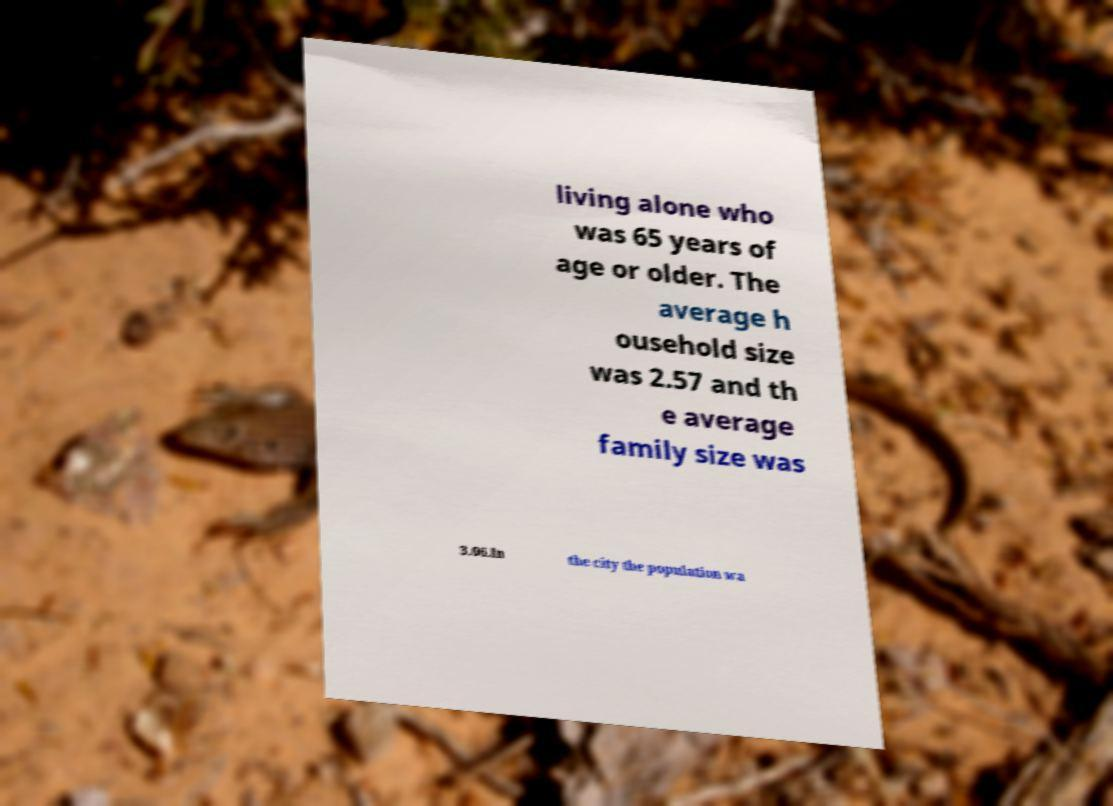Please identify and transcribe the text found in this image. living alone who was 65 years of age or older. The average h ousehold size was 2.57 and th e average family size was 3.06.In the city the population wa 